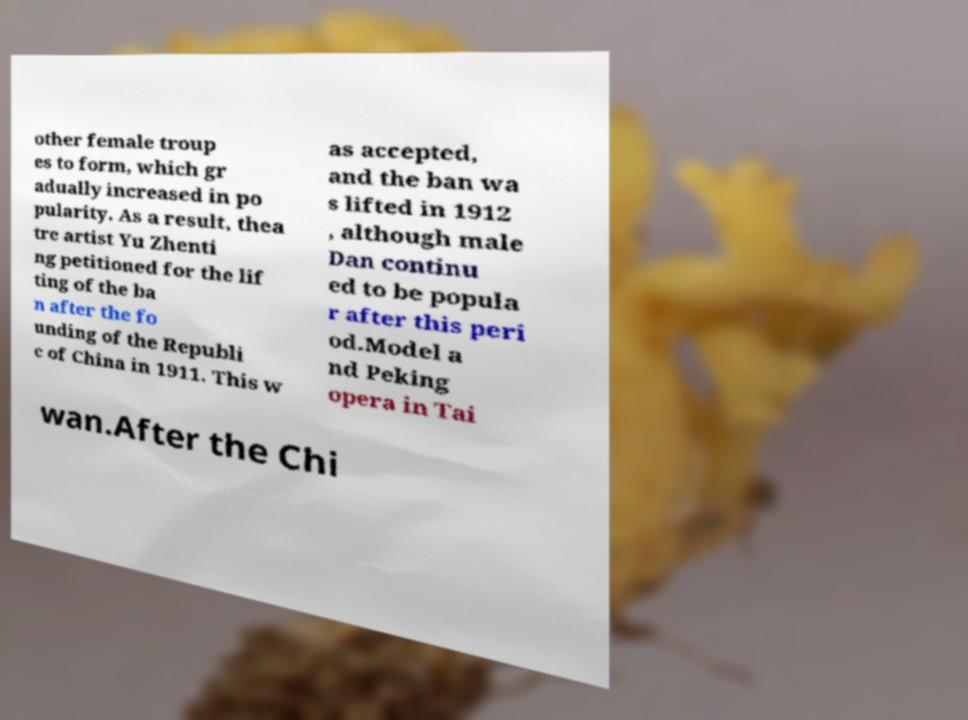Can you read and provide the text displayed in the image?This photo seems to have some interesting text. Can you extract and type it out for me? other female troup es to form, which gr adually increased in po pularity. As a result, thea tre artist Yu Zhenti ng petitioned for the lif ting of the ba n after the fo unding of the Republi c of China in 1911. This w as accepted, and the ban wa s lifted in 1912 , although male Dan continu ed to be popula r after this peri od.Model a nd Peking opera in Tai wan.After the Chi 